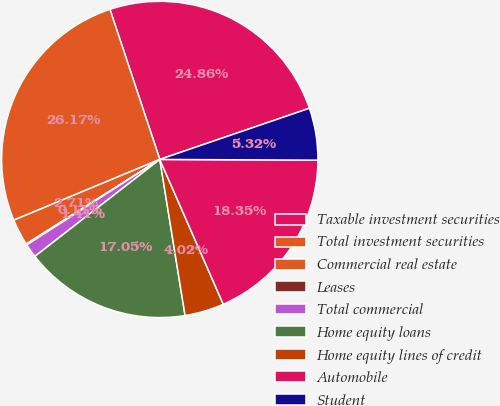Convert chart to OTSL. <chart><loc_0><loc_0><loc_500><loc_500><pie_chart><fcel>Taxable investment securities<fcel>Total investment securities<fcel>Commercial real estate<fcel>Leases<fcel>Total commercial<fcel>Home equity loans<fcel>Home equity lines of credit<fcel>Automobile<fcel>Student<nl><fcel>24.86%<fcel>26.17%<fcel>2.71%<fcel>0.11%<fcel>1.41%<fcel>17.05%<fcel>4.02%<fcel>18.35%<fcel>5.32%<nl></chart> 